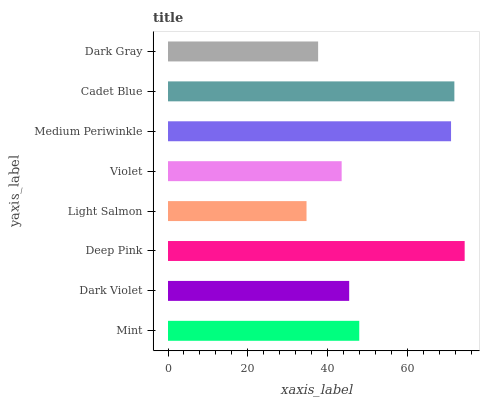Is Light Salmon the minimum?
Answer yes or no. Yes. Is Deep Pink the maximum?
Answer yes or no. Yes. Is Dark Violet the minimum?
Answer yes or no. No. Is Dark Violet the maximum?
Answer yes or no. No. Is Mint greater than Dark Violet?
Answer yes or no. Yes. Is Dark Violet less than Mint?
Answer yes or no. Yes. Is Dark Violet greater than Mint?
Answer yes or no. No. Is Mint less than Dark Violet?
Answer yes or no. No. Is Mint the high median?
Answer yes or no. Yes. Is Dark Violet the low median?
Answer yes or no. Yes. Is Deep Pink the high median?
Answer yes or no. No. Is Light Salmon the low median?
Answer yes or no. No. 